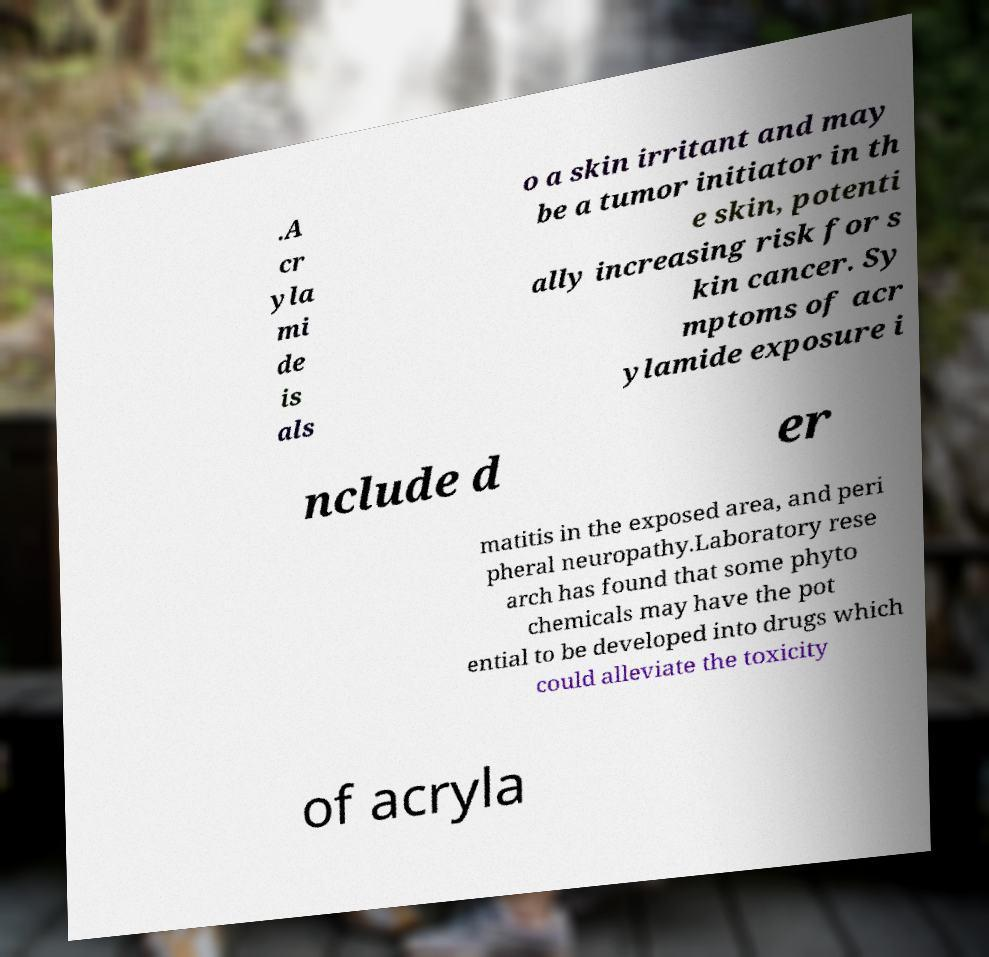Please read and relay the text visible in this image. What does it say? .A cr yla mi de is als o a skin irritant and may be a tumor initiator in th e skin, potenti ally increasing risk for s kin cancer. Sy mptoms of acr ylamide exposure i nclude d er matitis in the exposed area, and peri pheral neuropathy.Laboratory rese arch has found that some phyto chemicals may have the pot ential to be developed into drugs which could alleviate the toxicity of acryla 